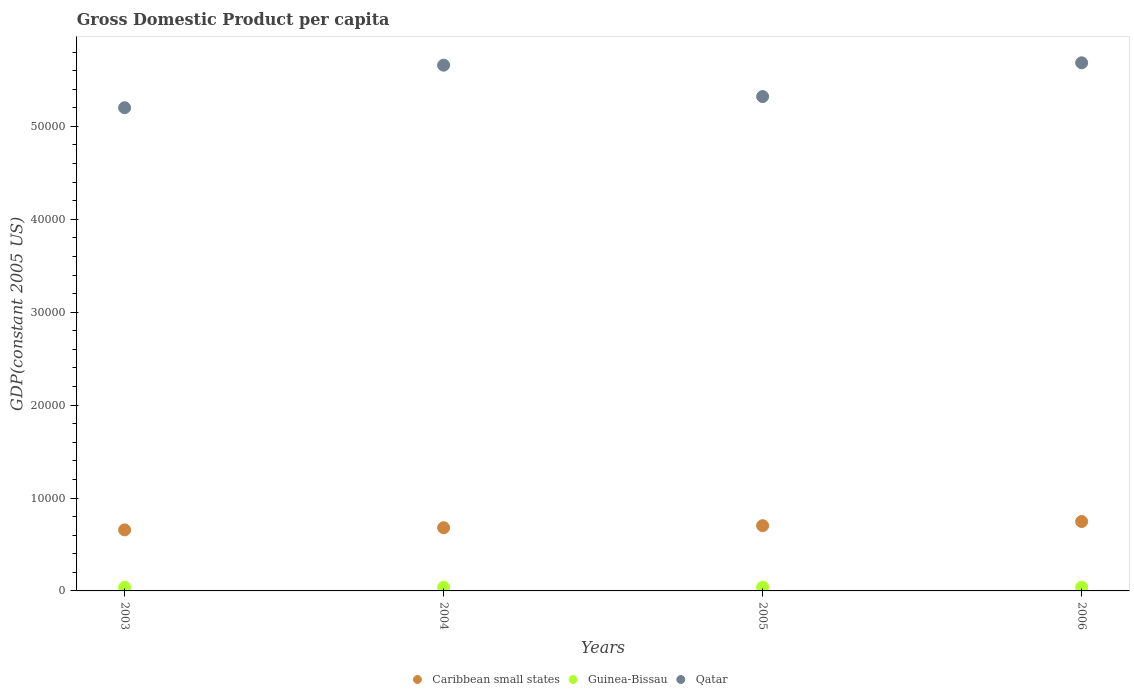How many different coloured dotlines are there?
Your response must be concise. 3. Is the number of dotlines equal to the number of legend labels?
Ensure brevity in your answer.  Yes. What is the GDP per capita in Caribbean small states in 2004?
Provide a succinct answer. 6801.26. Across all years, what is the maximum GDP per capita in Caribbean small states?
Your response must be concise. 7469.94. Across all years, what is the minimum GDP per capita in Caribbean small states?
Your answer should be compact. 6570.17. In which year was the GDP per capita in Caribbean small states maximum?
Your response must be concise. 2006. In which year was the GDP per capita in Qatar minimum?
Provide a succinct answer. 2003. What is the total GDP per capita in Caribbean small states in the graph?
Make the answer very short. 2.79e+04. What is the difference between the GDP per capita in Caribbean small states in 2004 and that in 2006?
Your answer should be very brief. -668.67. What is the difference between the GDP per capita in Guinea-Bissau in 2003 and the GDP per capita in Qatar in 2005?
Keep it short and to the point. -5.28e+04. What is the average GDP per capita in Qatar per year?
Offer a terse response. 5.47e+04. In the year 2006, what is the difference between the GDP per capita in Qatar and GDP per capita in Caribbean small states?
Make the answer very short. 4.94e+04. What is the ratio of the GDP per capita in Caribbean small states in 2003 to that in 2004?
Your answer should be very brief. 0.97. Is the GDP per capita in Guinea-Bissau in 2004 less than that in 2005?
Your answer should be compact. Yes. What is the difference between the highest and the second highest GDP per capita in Qatar?
Offer a terse response. 254.69. What is the difference between the highest and the lowest GDP per capita in Caribbean small states?
Offer a very short reply. 899.77. In how many years, is the GDP per capita in Guinea-Bissau greater than the average GDP per capita in Guinea-Bissau taken over all years?
Provide a succinct answer. 2. Is the sum of the GDP per capita in Qatar in 2003 and 2006 greater than the maximum GDP per capita in Guinea-Bissau across all years?
Give a very brief answer. Yes. Is it the case that in every year, the sum of the GDP per capita in Caribbean small states and GDP per capita in Guinea-Bissau  is greater than the GDP per capita in Qatar?
Offer a terse response. No. Does the GDP per capita in Caribbean small states monotonically increase over the years?
Keep it short and to the point. Yes. Is the GDP per capita in Qatar strictly greater than the GDP per capita in Guinea-Bissau over the years?
Offer a terse response. Yes. Is the GDP per capita in Guinea-Bissau strictly less than the GDP per capita in Qatar over the years?
Your response must be concise. Yes. How many dotlines are there?
Give a very brief answer. 3. Are the values on the major ticks of Y-axis written in scientific E-notation?
Ensure brevity in your answer.  No. How are the legend labels stacked?
Ensure brevity in your answer.  Horizontal. What is the title of the graph?
Keep it short and to the point. Gross Domestic Product per capita. Does "Kuwait" appear as one of the legend labels in the graph?
Make the answer very short. No. What is the label or title of the X-axis?
Keep it short and to the point. Years. What is the label or title of the Y-axis?
Provide a short and direct response. GDP(constant 2005 US). What is the GDP(constant 2005 US) in Caribbean small states in 2003?
Your answer should be very brief. 6570.17. What is the GDP(constant 2005 US) in Guinea-Bissau in 2003?
Make the answer very short. 390.71. What is the GDP(constant 2005 US) of Qatar in 2003?
Your response must be concise. 5.20e+04. What is the GDP(constant 2005 US) in Caribbean small states in 2004?
Keep it short and to the point. 6801.26. What is the GDP(constant 2005 US) of Guinea-Bissau in 2004?
Your answer should be compact. 393.06. What is the GDP(constant 2005 US) in Qatar in 2004?
Provide a succinct answer. 5.66e+04. What is the GDP(constant 2005 US) in Caribbean small states in 2005?
Give a very brief answer. 7021.17. What is the GDP(constant 2005 US) in Guinea-Bissau in 2005?
Your answer should be very brief. 401.15. What is the GDP(constant 2005 US) in Qatar in 2005?
Give a very brief answer. 5.32e+04. What is the GDP(constant 2005 US) of Caribbean small states in 2006?
Offer a very short reply. 7469.94. What is the GDP(constant 2005 US) in Guinea-Bissau in 2006?
Keep it short and to the point. 401.68. What is the GDP(constant 2005 US) of Qatar in 2006?
Provide a short and direct response. 5.68e+04. Across all years, what is the maximum GDP(constant 2005 US) in Caribbean small states?
Keep it short and to the point. 7469.94. Across all years, what is the maximum GDP(constant 2005 US) in Guinea-Bissau?
Make the answer very short. 401.68. Across all years, what is the maximum GDP(constant 2005 US) in Qatar?
Provide a succinct answer. 5.68e+04. Across all years, what is the minimum GDP(constant 2005 US) in Caribbean small states?
Ensure brevity in your answer.  6570.17. Across all years, what is the minimum GDP(constant 2005 US) in Guinea-Bissau?
Your answer should be compact. 390.71. Across all years, what is the minimum GDP(constant 2005 US) in Qatar?
Keep it short and to the point. 5.20e+04. What is the total GDP(constant 2005 US) of Caribbean small states in the graph?
Make the answer very short. 2.79e+04. What is the total GDP(constant 2005 US) of Guinea-Bissau in the graph?
Provide a short and direct response. 1586.59. What is the total GDP(constant 2005 US) in Qatar in the graph?
Your response must be concise. 2.19e+05. What is the difference between the GDP(constant 2005 US) of Caribbean small states in 2003 and that in 2004?
Provide a succinct answer. -231.09. What is the difference between the GDP(constant 2005 US) of Guinea-Bissau in 2003 and that in 2004?
Your answer should be very brief. -2.35. What is the difference between the GDP(constant 2005 US) of Qatar in 2003 and that in 2004?
Your answer should be very brief. -4580.65. What is the difference between the GDP(constant 2005 US) in Caribbean small states in 2003 and that in 2005?
Your answer should be compact. -451. What is the difference between the GDP(constant 2005 US) in Guinea-Bissau in 2003 and that in 2005?
Provide a succinct answer. -10.44. What is the difference between the GDP(constant 2005 US) of Qatar in 2003 and that in 2005?
Your answer should be very brief. -1201.82. What is the difference between the GDP(constant 2005 US) in Caribbean small states in 2003 and that in 2006?
Your answer should be compact. -899.77. What is the difference between the GDP(constant 2005 US) in Guinea-Bissau in 2003 and that in 2006?
Offer a very short reply. -10.97. What is the difference between the GDP(constant 2005 US) of Qatar in 2003 and that in 2006?
Offer a very short reply. -4835.34. What is the difference between the GDP(constant 2005 US) of Caribbean small states in 2004 and that in 2005?
Offer a terse response. -219.9. What is the difference between the GDP(constant 2005 US) of Guinea-Bissau in 2004 and that in 2005?
Offer a terse response. -8.09. What is the difference between the GDP(constant 2005 US) in Qatar in 2004 and that in 2005?
Your answer should be compact. 3378.83. What is the difference between the GDP(constant 2005 US) in Caribbean small states in 2004 and that in 2006?
Your answer should be compact. -668.67. What is the difference between the GDP(constant 2005 US) in Guinea-Bissau in 2004 and that in 2006?
Make the answer very short. -8.62. What is the difference between the GDP(constant 2005 US) of Qatar in 2004 and that in 2006?
Provide a succinct answer. -254.69. What is the difference between the GDP(constant 2005 US) of Caribbean small states in 2005 and that in 2006?
Your answer should be very brief. -448.77. What is the difference between the GDP(constant 2005 US) in Guinea-Bissau in 2005 and that in 2006?
Keep it short and to the point. -0.53. What is the difference between the GDP(constant 2005 US) of Qatar in 2005 and that in 2006?
Ensure brevity in your answer.  -3633.53. What is the difference between the GDP(constant 2005 US) in Caribbean small states in 2003 and the GDP(constant 2005 US) in Guinea-Bissau in 2004?
Offer a terse response. 6177.11. What is the difference between the GDP(constant 2005 US) of Caribbean small states in 2003 and the GDP(constant 2005 US) of Qatar in 2004?
Your response must be concise. -5.00e+04. What is the difference between the GDP(constant 2005 US) of Guinea-Bissau in 2003 and the GDP(constant 2005 US) of Qatar in 2004?
Your answer should be compact. -5.62e+04. What is the difference between the GDP(constant 2005 US) in Caribbean small states in 2003 and the GDP(constant 2005 US) in Guinea-Bissau in 2005?
Offer a very short reply. 6169.02. What is the difference between the GDP(constant 2005 US) of Caribbean small states in 2003 and the GDP(constant 2005 US) of Qatar in 2005?
Your answer should be very brief. -4.66e+04. What is the difference between the GDP(constant 2005 US) of Guinea-Bissau in 2003 and the GDP(constant 2005 US) of Qatar in 2005?
Offer a very short reply. -5.28e+04. What is the difference between the GDP(constant 2005 US) in Caribbean small states in 2003 and the GDP(constant 2005 US) in Guinea-Bissau in 2006?
Your response must be concise. 6168.49. What is the difference between the GDP(constant 2005 US) in Caribbean small states in 2003 and the GDP(constant 2005 US) in Qatar in 2006?
Your answer should be very brief. -5.03e+04. What is the difference between the GDP(constant 2005 US) of Guinea-Bissau in 2003 and the GDP(constant 2005 US) of Qatar in 2006?
Your answer should be very brief. -5.65e+04. What is the difference between the GDP(constant 2005 US) of Caribbean small states in 2004 and the GDP(constant 2005 US) of Guinea-Bissau in 2005?
Make the answer very short. 6400.12. What is the difference between the GDP(constant 2005 US) in Caribbean small states in 2004 and the GDP(constant 2005 US) in Qatar in 2005?
Make the answer very short. -4.64e+04. What is the difference between the GDP(constant 2005 US) of Guinea-Bissau in 2004 and the GDP(constant 2005 US) of Qatar in 2005?
Make the answer very short. -5.28e+04. What is the difference between the GDP(constant 2005 US) of Caribbean small states in 2004 and the GDP(constant 2005 US) of Guinea-Bissau in 2006?
Ensure brevity in your answer.  6399.59. What is the difference between the GDP(constant 2005 US) in Caribbean small states in 2004 and the GDP(constant 2005 US) in Qatar in 2006?
Offer a terse response. -5.00e+04. What is the difference between the GDP(constant 2005 US) of Guinea-Bissau in 2004 and the GDP(constant 2005 US) of Qatar in 2006?
Make the answer very short. -5.64e+04. What is the difference between the GDP(constant 2005 US) of Caribbean small states in 2005 and the GDP(constant 2005 US) of Guinea-Bissau in 2006?
Your answer should be compact. 6619.49. What is the difference between the GDP(constant 2005 US) in Caribbean small states in 2005 and the GDP(constant 2005 US) in Qatar in 2006?
Offer a very short reply. -4.98e+04. What is the difference between the GDP(constant 2005 US) of Guinea-Bissau in 2005 and the GDP(constant 2005 US) of Qatar in 2006?
Your answer should be very brief. -5.64e+04. What is the average GDP(constant 2005 US) of Caribbean small states per year?
Offer a terse response. 6965.63. What is the average GDP(constant 2005 US) of Guinea-Bissau per year?
Your answer should be very brief. 396.65. What is the average GDP(constant 2005 US) of Qatar per year?
Provide a short and direct response. 5.47e+04. In the year 2003, what is the difference between the GDP(constant 2005 US) of Caribbean small states and GDP(constant 2005 US) of Guinea-Bissau?
Offer a very short reply. 6179.46. In the year 2003, what is the difference between the GDP(constant 2005 US) of Caribbean small states and GDP(constant 2005 US) of Qatar?
Ensure brevity in your answer.  -4.54e+04. In the year 2003, what is the difference between the GDP(constant 2005 US) of Guinea-Bissau and GDP(constant 2005 US) of Qatar?
Your answer should be very brief. -5.16e+04. In the year 2004, what is the difference between the GDP(constant 2005 US) in Caribbean small states and GDP(constant 2005 US) in Guinea-Bissau?
Provide a succinct answer. 6408.21. In the year 2004, what is the difference between the GDP(constant 2005 US) in Caribbean small states and GDP(constant 2005 US) in Qatar?
Provide a short and direct response. -4.98e+04. In the year 2004, what is the difference between the GDP(constant 2005 US) of Guinea-Bissau and GDP(constant 2005 US) of Qatar?
Make the answer very short. -5.62e+04. In the year 2005, what is the difference between the GDP(constant 2005 US) of Caribbean small states and GDP(constant 2005 US) of Guinea-Bissau?
Your answer should be very brief. 6620.02. In the year 2005, what is the difference between the GDP(constant 2005 US) of Caribbean small states and GDP(constant 2005 US) of Qatar?
Keep it short and to the point. -4.62e+04. In the year 2005, what is the difference between the GDP(constant 2005 US) in Guinea-Bissau and GDP(constant 2005 US) in Qatar?
Your answer should be very brief. -5.28e+04. In the year 2006, what is the difference between the GDP(constant 2005 US) of Caribbean small states and GDP(constant 2005 US) of Guinea-Bissau?
Your response must be concise. 7068.26. In the year 2006, what is the difference between the GDP(constant 2005 US) in Caribbean small states and GDP(constant 2005 US) in Qatar?
Provide a short and direct response. -4.94e+04. In the year 2006, what is the difference between the GDP(constant 2005 US) in Guinea-Bissau and GDP(constant 2005 US) in Qatar?
Provide a succinct answer. -5.64e+04. What is the ratio of the GDP(constant 2005 US) of Caribbean small states in 2003 to that in 2004?
Keep it short and to the point. 0.97. What is the ratio of the GDP(constant 2005 US) of Guinea-Bissau in 2003 to that in 2004?
Give a very brief answer. 0.99. What is the ratio of the GDP(constant 2005 US) in Qatar in 2003 to that in 2004?
Your response must be concise. 0.92. What is the ratio of the GDP(constant 2005 US) of Caribbean small states in 2003 to that in 2005?
Give a very brief answer. 0.94. What is the ratio of the GDP(constant 2005 US) in Qatar in 2003 to that in 2005?
Offer a very short reply. 0.98. What is the ratio of the GDP(constant 2005 US) of Caribbean small states in 2003 to that in 2006?
Provide a short and direct response. 0.88. What is the ratio of the GDP(constant 2005 US) in Guinea-Bissau in 2003 to that in 2006?
Your response must be concise. 0.97. What is the ratio of the GDP(constant 2005 US) of Qatar in 2003 to that in 2006?
Ensure brevity in your answer.  0.91. What is the ratio of the GDP(constant 2005 US) of Caribbean small states in 2004 to that in 2005?
Provide a succinct answer. 0.97. What is the ratio of the GDP(constant 2005 US) in Guinea-Bissau in 2004 to that in 2005?
Provide a succinct answer. 0.98. What is the ratio of the GDP(constant 2005 US) of Qatar in 2004 to that in 2005?
Your response must be concise. 1.06. What is the ratio of the GDP(constant 2005 US) in Caribbean small states in 2004 to that in 2006?
Your response must be concise. 0.91. What is the ratio of the GDP(constant 2005 US) of Guinea-Bissau in 2004 to that in 2006?
Your answer should be very brief. 0.98. What is the ratio of the GDP(constant 2005 US) in Caribbean small states in 2005 to that in 2006?
Keep it short and to the point. 0.94. What is the ratio of the GDP(constant 2005 US) in Qatar in 2005 to that in 2006?
Keep it short and to the point. 0.94. What is the difference between the highest and the second highest GDP(constant 2005 US) in Caribbean small states?
Make the answer very short. 448.77. What is the difference between the highest and the second highest GDP(constant 2005 US) in Guinea-Bissau?
Give a very brief answer. 0.53. What is the difference between the highest and the second highest GDP(constant 2005 US) of Qatar?
Keep it short and to the point. 254.69. What is the difference between the highest and the lowest GDP(constant 2005 US) in Caribbean small states?
Make the answer very short. 899.77. What is the difference between the highest and the lowest GDP(constant 2005 US) of Guinea-Bissau?
Keep it short and to the point. 10.97. What is the difference between the highest and the lowest GDP(constant 2005 US) in Qatar?
Offer a very short reply. 4835.34. 